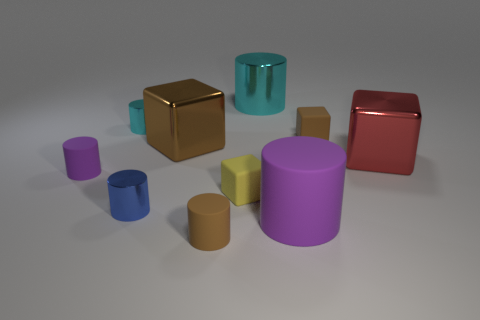Subtract all yellow cubes. How many cubes are left? 3 Subtract all small blue cylinders. How many cylinders are left? 5 Subtract 0 green spheres. How many objects are left? 10 Subtract all cubes. How many objects are left? 6 Subtract 2 blocks. How many blocks are left? 2 Subtract all brown blocks. Subtract all yellow cylinders. How many blocks are left? 2 Subtract all cyan balls. How many brown cylinders are left? 1 Subtract all small brown cubes. Subtract all cyan rubber blocks. How many objects are left? 9 Add 9 tiny yellow rubber objects. How many tiny yellow rubber objects are left? 10 Add 2 brown cylinders. How many brown cylinders exist? 3 